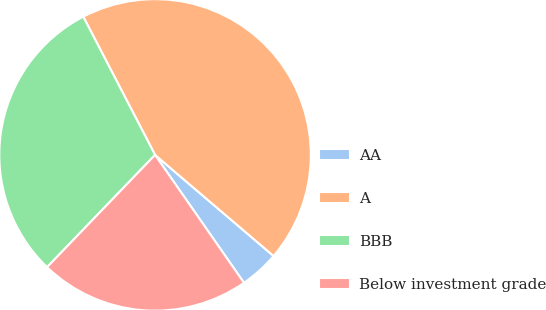Convert chart. <chart><loc_0><loc_0><loc_500><loc_500><pie_chart><fcel>AA<fcel>A<fcel>BBB<fcel>Below investment grade<nl><fcel>4.09%<fcel>43.86%<fcel>30.18%<fcel>21.86%<nl></chart> 